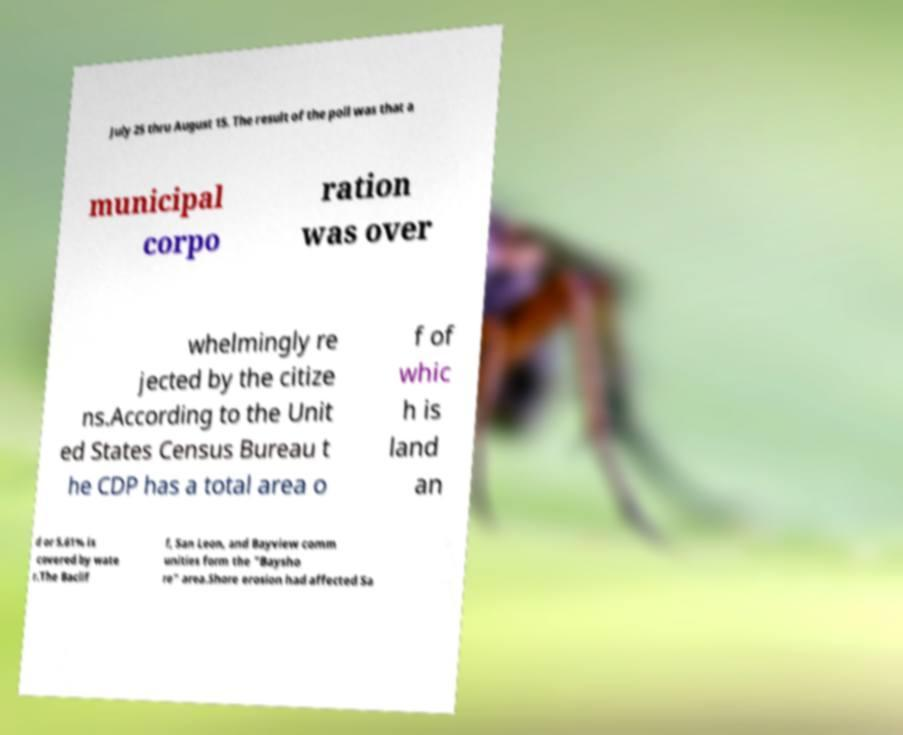I need the written content from this picture converted into text. Can you do that? July 25 thru August 15. The result of the poll was that a municipal corpo ration was over whelmingly re jected by the citize ns.According to the Unit ed States Census Bureau t he CDP has a total area o f of whic h is land an d or 5.61% is covered by wate r.The Baclif f, San Leon, and Bayview comm unities form the "Baysho re" area.Shore erosion had affected Sa 